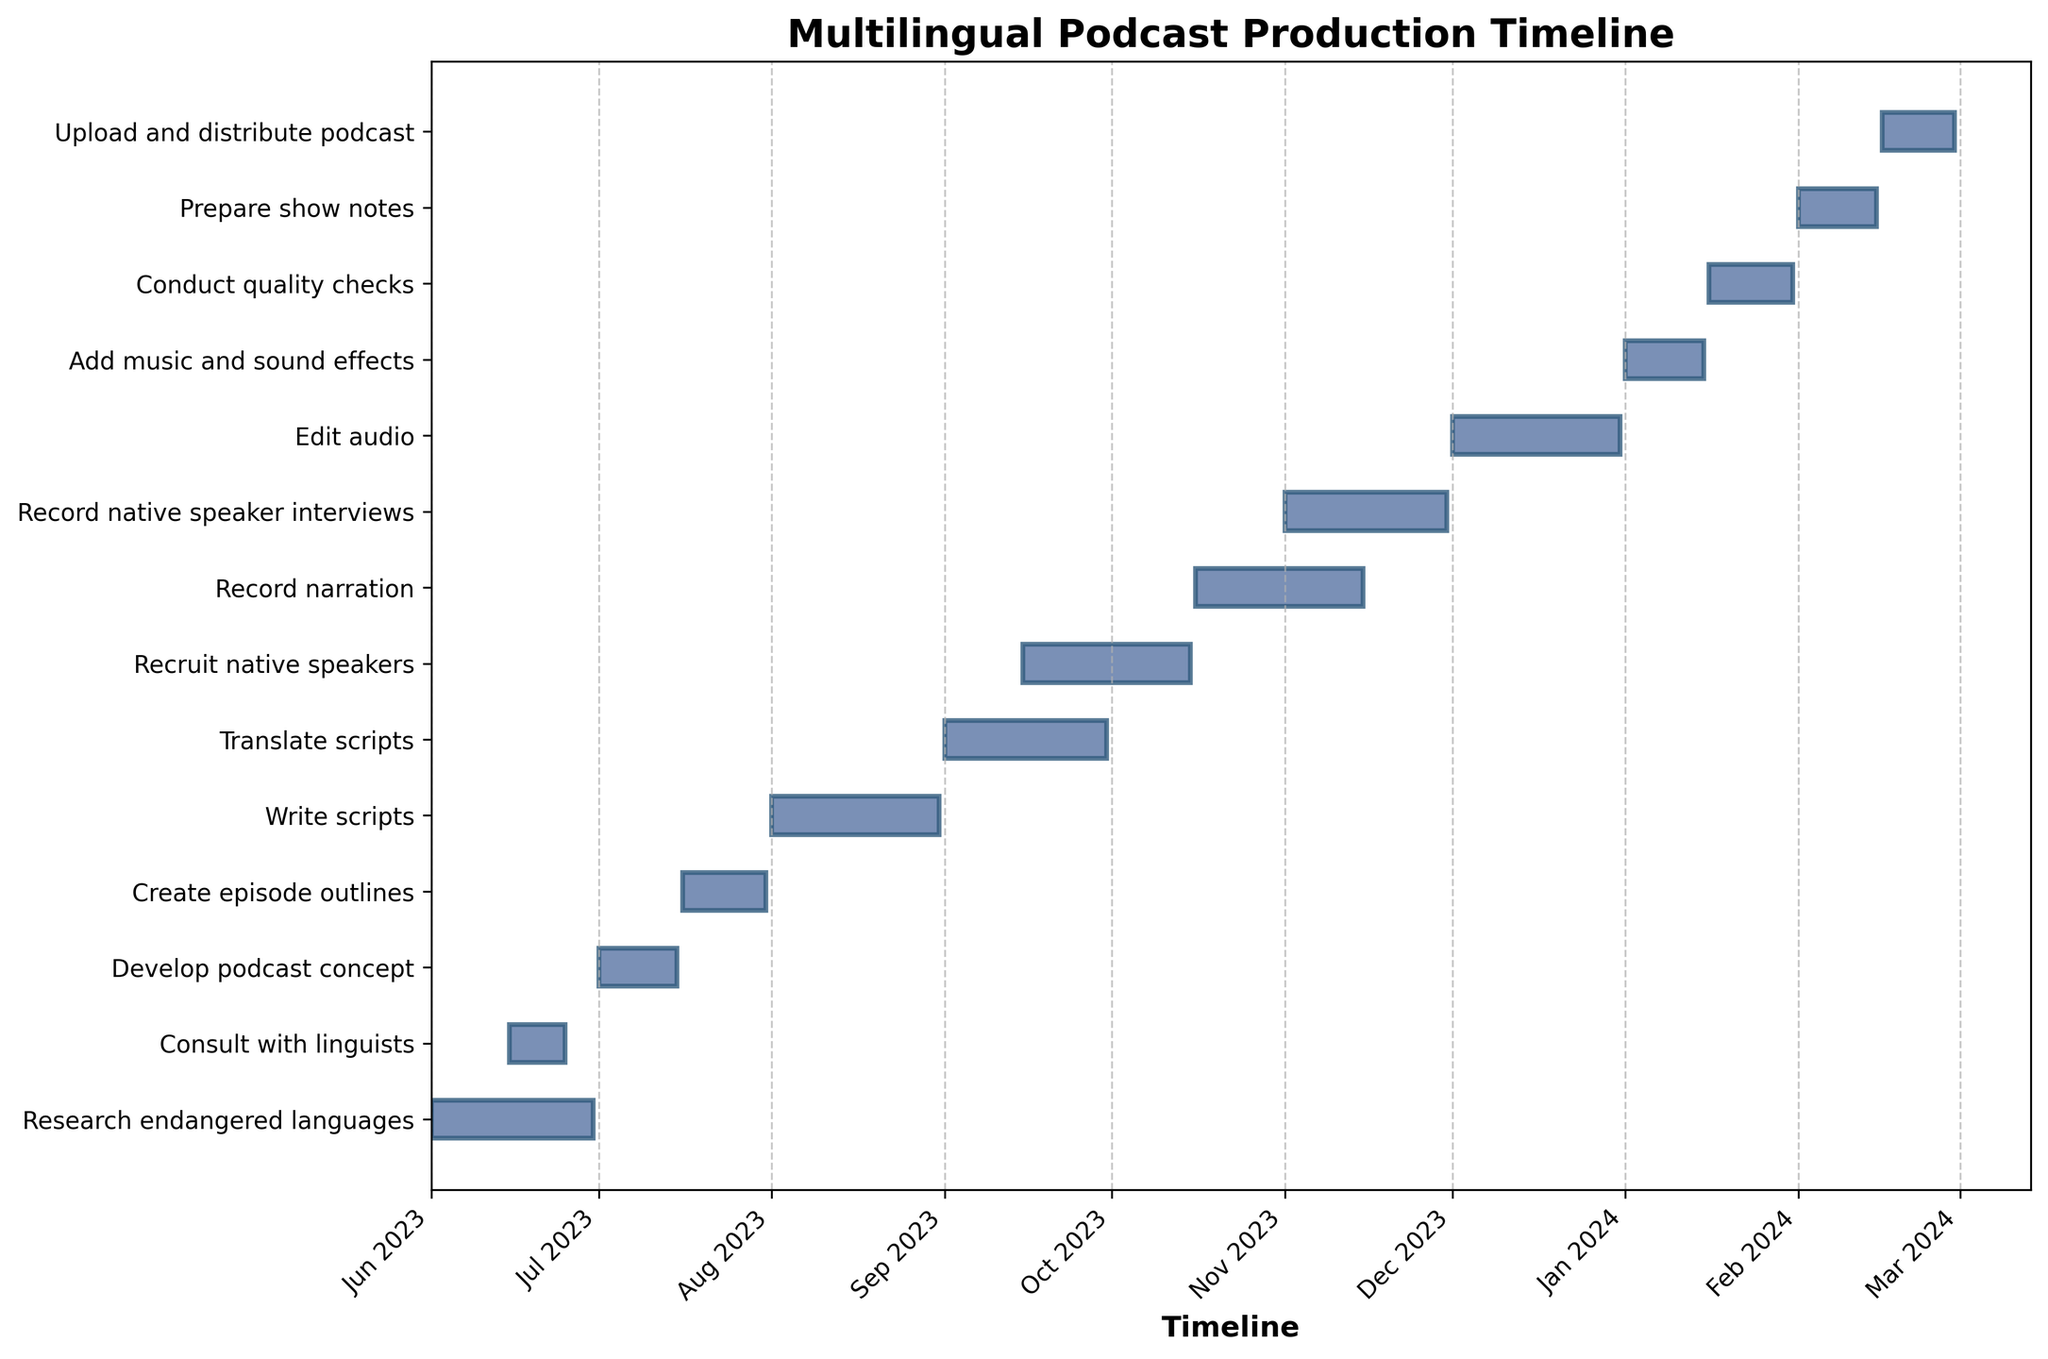Which task has the shortest duration? By observing the lengths of the bars representing each task, the shortest bar corresponds to the task "Upload and distribute podcast." This indicates that it has the shortest duration.
Answer: Upload and distribute podcast What is the timeline range for "Write scripts"? The bars indicate the start and end dates, where "Write scripts" begins on Aug 1, 2023, and ends on Aug 31, 2023.
Answer: Aug 1, 2023 to Aug 31, 2023 Which task overlaps with "Translate scripts"? By looking at the timeline, "Recruit native speakers" overlaps because it starts on Sep 15, 2023, while "Translate scripts" runs from Sep 1, 2023, to Sep 30, 2023.
Answer: Recruit native speakers How long is the "Edit audio" phase? The length of the bar for "Edit audio" from Dec 1, 2023, to Dec 31, 2023, shows a duration of 31 days.
Answer: 31 days What phase comes immediately after "Conduct quality checks"? Observing the sequence of bars, "Prepare show notes" begins right after "Conduct quality checks" ends on Jan 31, 2024.
Answer: Prepare show notes How many tasks are planned to be worked on during October 2023? By examining the Gantt chart for bars that occupy the timeline for October 2023, "Translate scripts," and "Recruit native speakers," and "Record narration" are ongoing.
Answer: 3 Which two tasks are scheduled to start on the same day? The bars aligned with the timeline show that "Add music and sound effects" and "Conduct quality checks" both start on Jan 1, 2024.
Answer: Add music and sound effects and Conduct quality checks Does "Record native speaker interviews" overlap with "Edit audio"? By checking the bars, "Record native speaker interviews" ends on Nov 30, 2023, and "Edit audio" starts on Dec 1, 2023. There is no overlap.
Answer: No Which month has the highest number of ongoing tasks? By counting the tasks for each month, October 2023 has three ongoing tasks ("Translate scripts," "Recruit native speakers," and "Record narration").
Answer: October 2023 When does the "Develop podcast concept" stage finish? Checking the timeline, "Develop podcast concept" ends on Jul 15, 2023.
Answer: Jul 15, 2023 